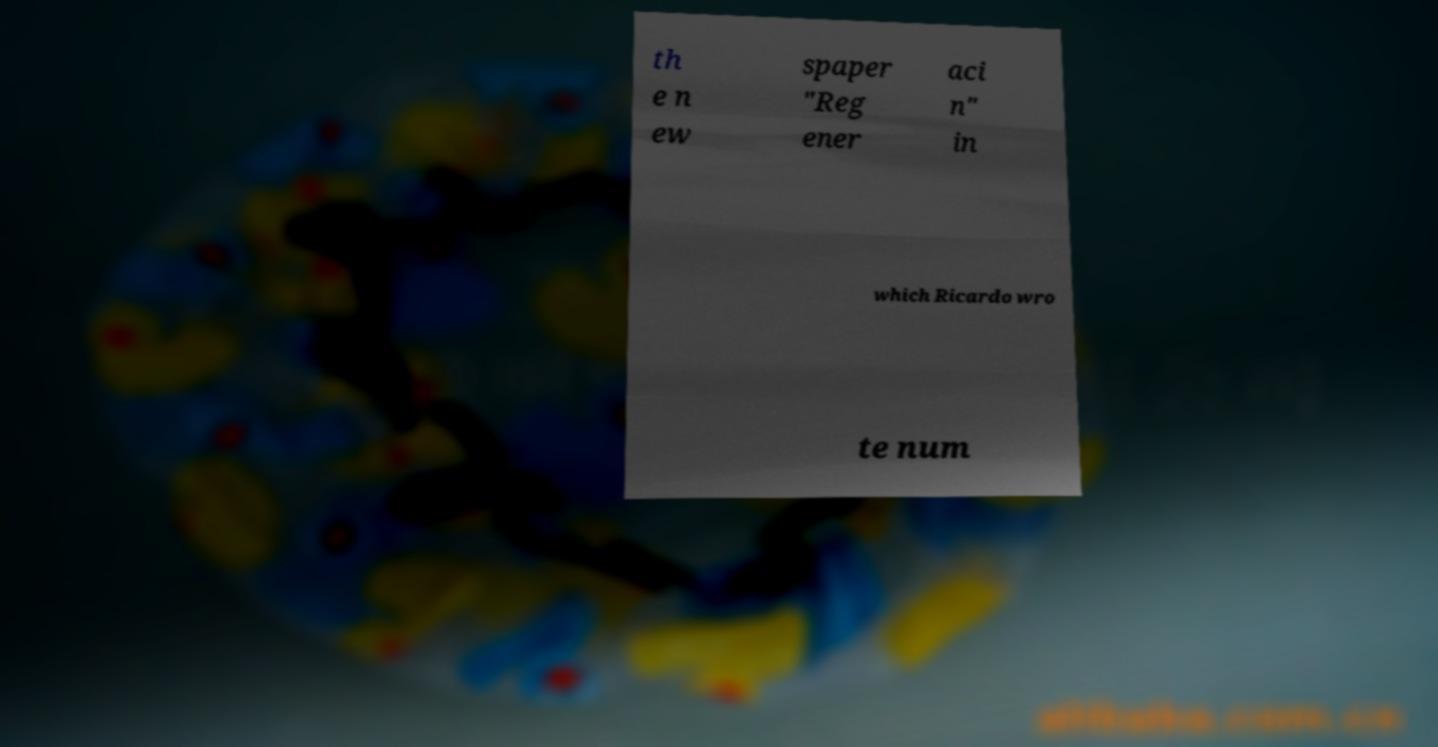Could you assist in decoding the text presented in this image and type it out clearly? th e n ew spaper "Reg ener aci n" in which Ricardo wro te num 